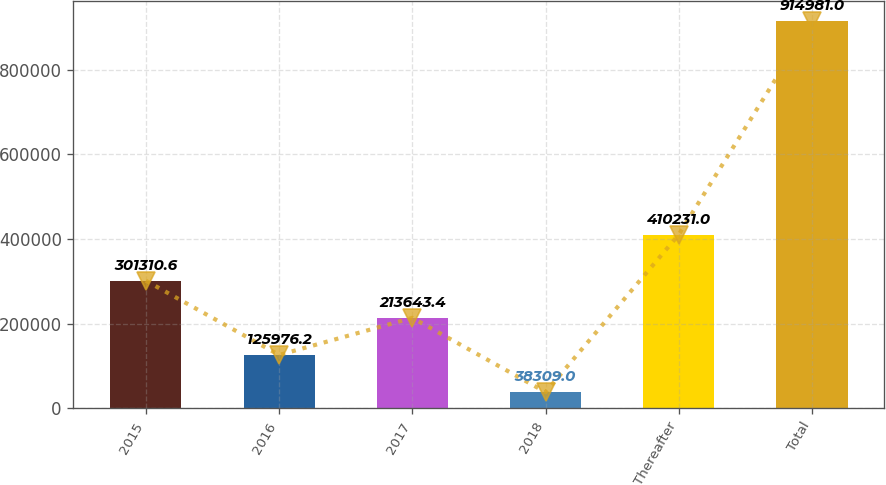<chart> <loc_0><loc_0><loc_500><loc_500><bar_chart><fcel>2015<fcel>2016<fcel>2017<fcel>2018<fcel>Thereafter<fcel>Total<nl><fcel>301311<fcel>125976<fcel>213643<fcel>38309<fcel>410231<fcel>914981<nl></chart> 